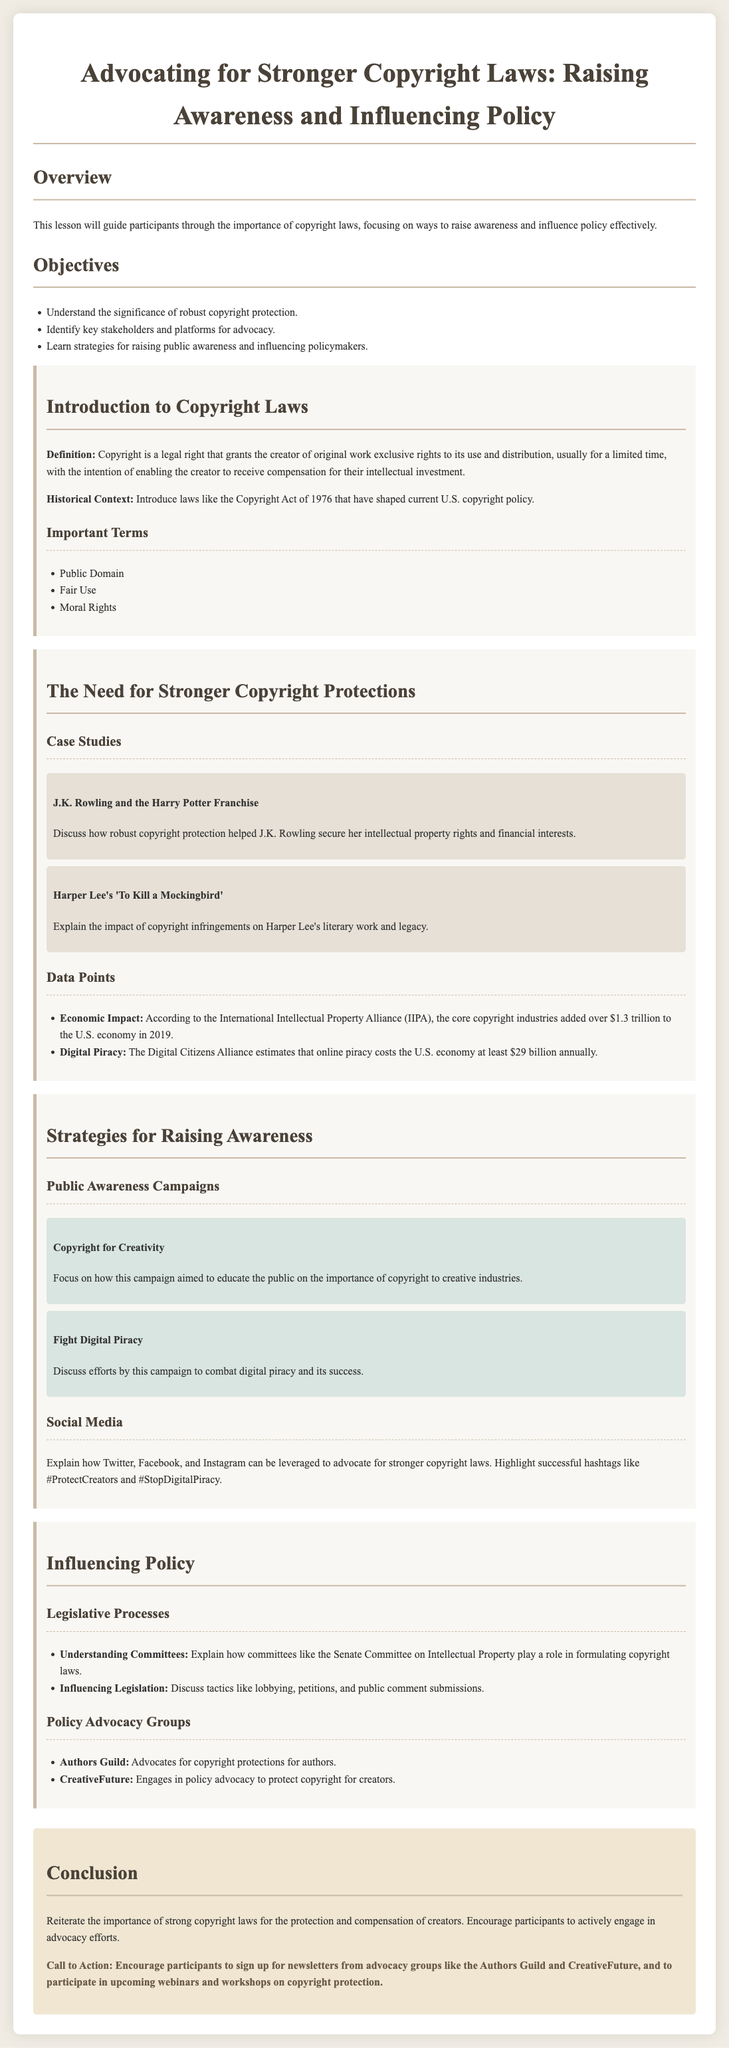What is the main purpose of the lesson plan? The main purpose of the lesson plan is to guide participants through the importance of copyright laws, focusing on ways to raise awareness and influence policy effectively.
Answer: Raising awareness and influencing policy What significant copyright law is mentioned in the document? The document mentions the Copyright Act of 1976 as a significant law that has shaped current U.S. copyright policy.
Answer: Copyright Act of 1976 Which two authors' works are discussed in the case studies? The case studies focus on J.K. Rowling and Harper Lee’s literary works, highlighting their experiences with copyright protection.
Answer: J.K. Rowling and Harper Lee What economic impact does the core copyright industries have, according to the IIPA? The document states that the core copyright industries added over $1.3 trillion to the U.S. economy in 2019, according to the IIPA.
Answer: Over $1.3 trillion What two campaigns are mentioned as strategies for raising public awareness? The campaigns mentioned for raising public awareness are "Copyright for Creativity" and "Fight Digital Piracy."
Answer: Copyright for Creativity and Fight Digital Piracy Which policy advocacy group specifically advocates for copyright protections for authors? The Authors Guild is identified in the document as a policy advocacy group that advocates for copyright protections for authors.
Answer: Authors Guild What is one method of influencing legislation mentioned in the lesson plan? The lesson plan highlights lobbying as one of the methods to influence legislation regarding copyright laws.
Answer: Lobbying What call to action is encouraged at the conclusion of the lesson plan? At the conclusion, participants are encouraged to sign up for newsletters from advocacy groups and to participate in upcoming webinars and workshops.
Answer: Sign up for newsletters and participate in webinars 